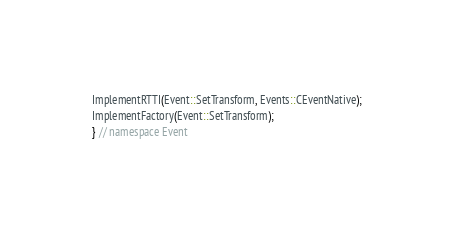<code> <loc_0><loc_0><loc_500><loc_500><_C++_>ImplementRTTI(Event::SetTransform, Events::CEventNative);
ImplementFactory(Event::SetTransform);
} // namespace Event
</code> 